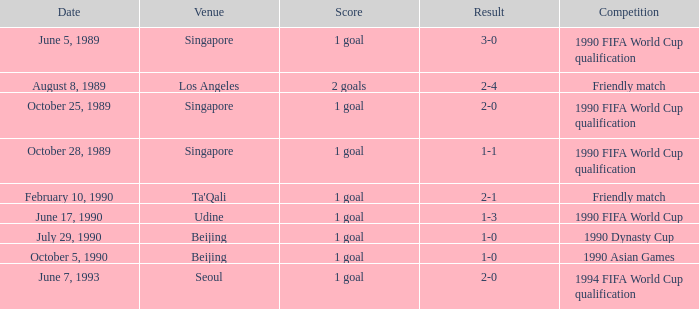What was the outcome of the game on july 29, 1990? 1 goal. 